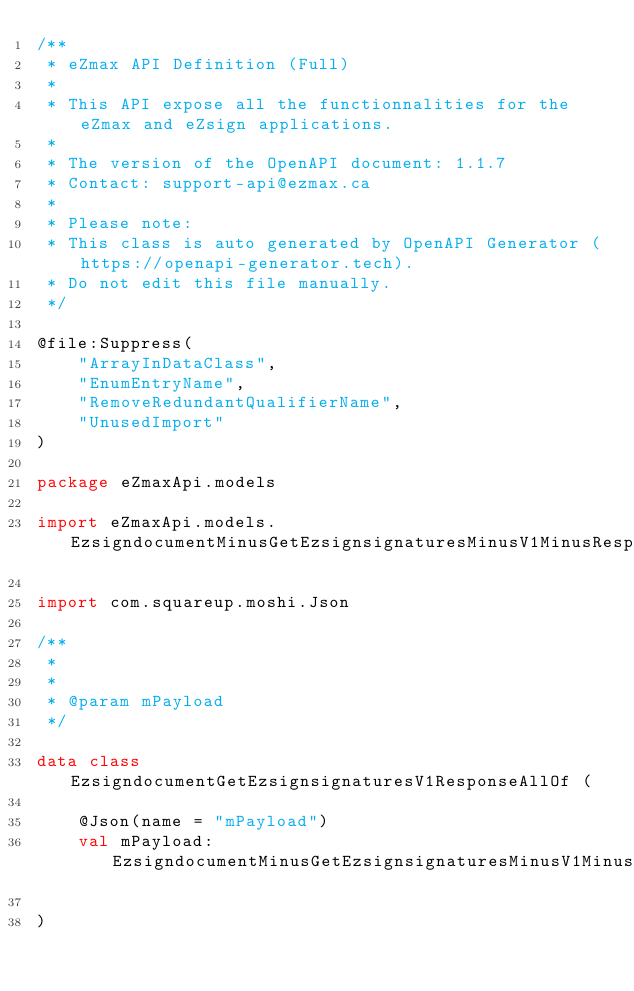Convert code to text. <code><loc_0><loc_0><loc_500><loc_500><_Kotlin_>/**
 * eZmax API Definition (Full)
 *
 * This API expose all the functionnalities for the eZmax and eZsign applications.
 *
 * The version of the OpenAPI document: 1.1.7
 * Contact: support-api@ezmax.ca
 *
 * Please note:
 * This class is auto generated by OpenAPI Generator (https://openapi-generator.tech).
 * Do not edit this file manually.
 */

@file:Suppress(
    "ArrayInDataClass",
    "EnumEntryName",
    "RemoveRedundantQualifierName",
    "UnusedImport"
)

package eZmaxApi.models

import eZmaxApi.models.EzsigndocumentMinusGetEzsignsignaturesMinusV1MinusResponseMinusMPayload

import com.squareup.moshi.Json

/**
 * 
 *
 * @param mPayload 
 */

data class EzsigndocumentGetEzsignsignaturesV1ResponseAllOf (

    @Json(name = "mPayload")
    val mPayload: EzsigndocumentMinusGetEzsignsignaturesMinusV1MinusResponseMinusMPayload

)

</code> 